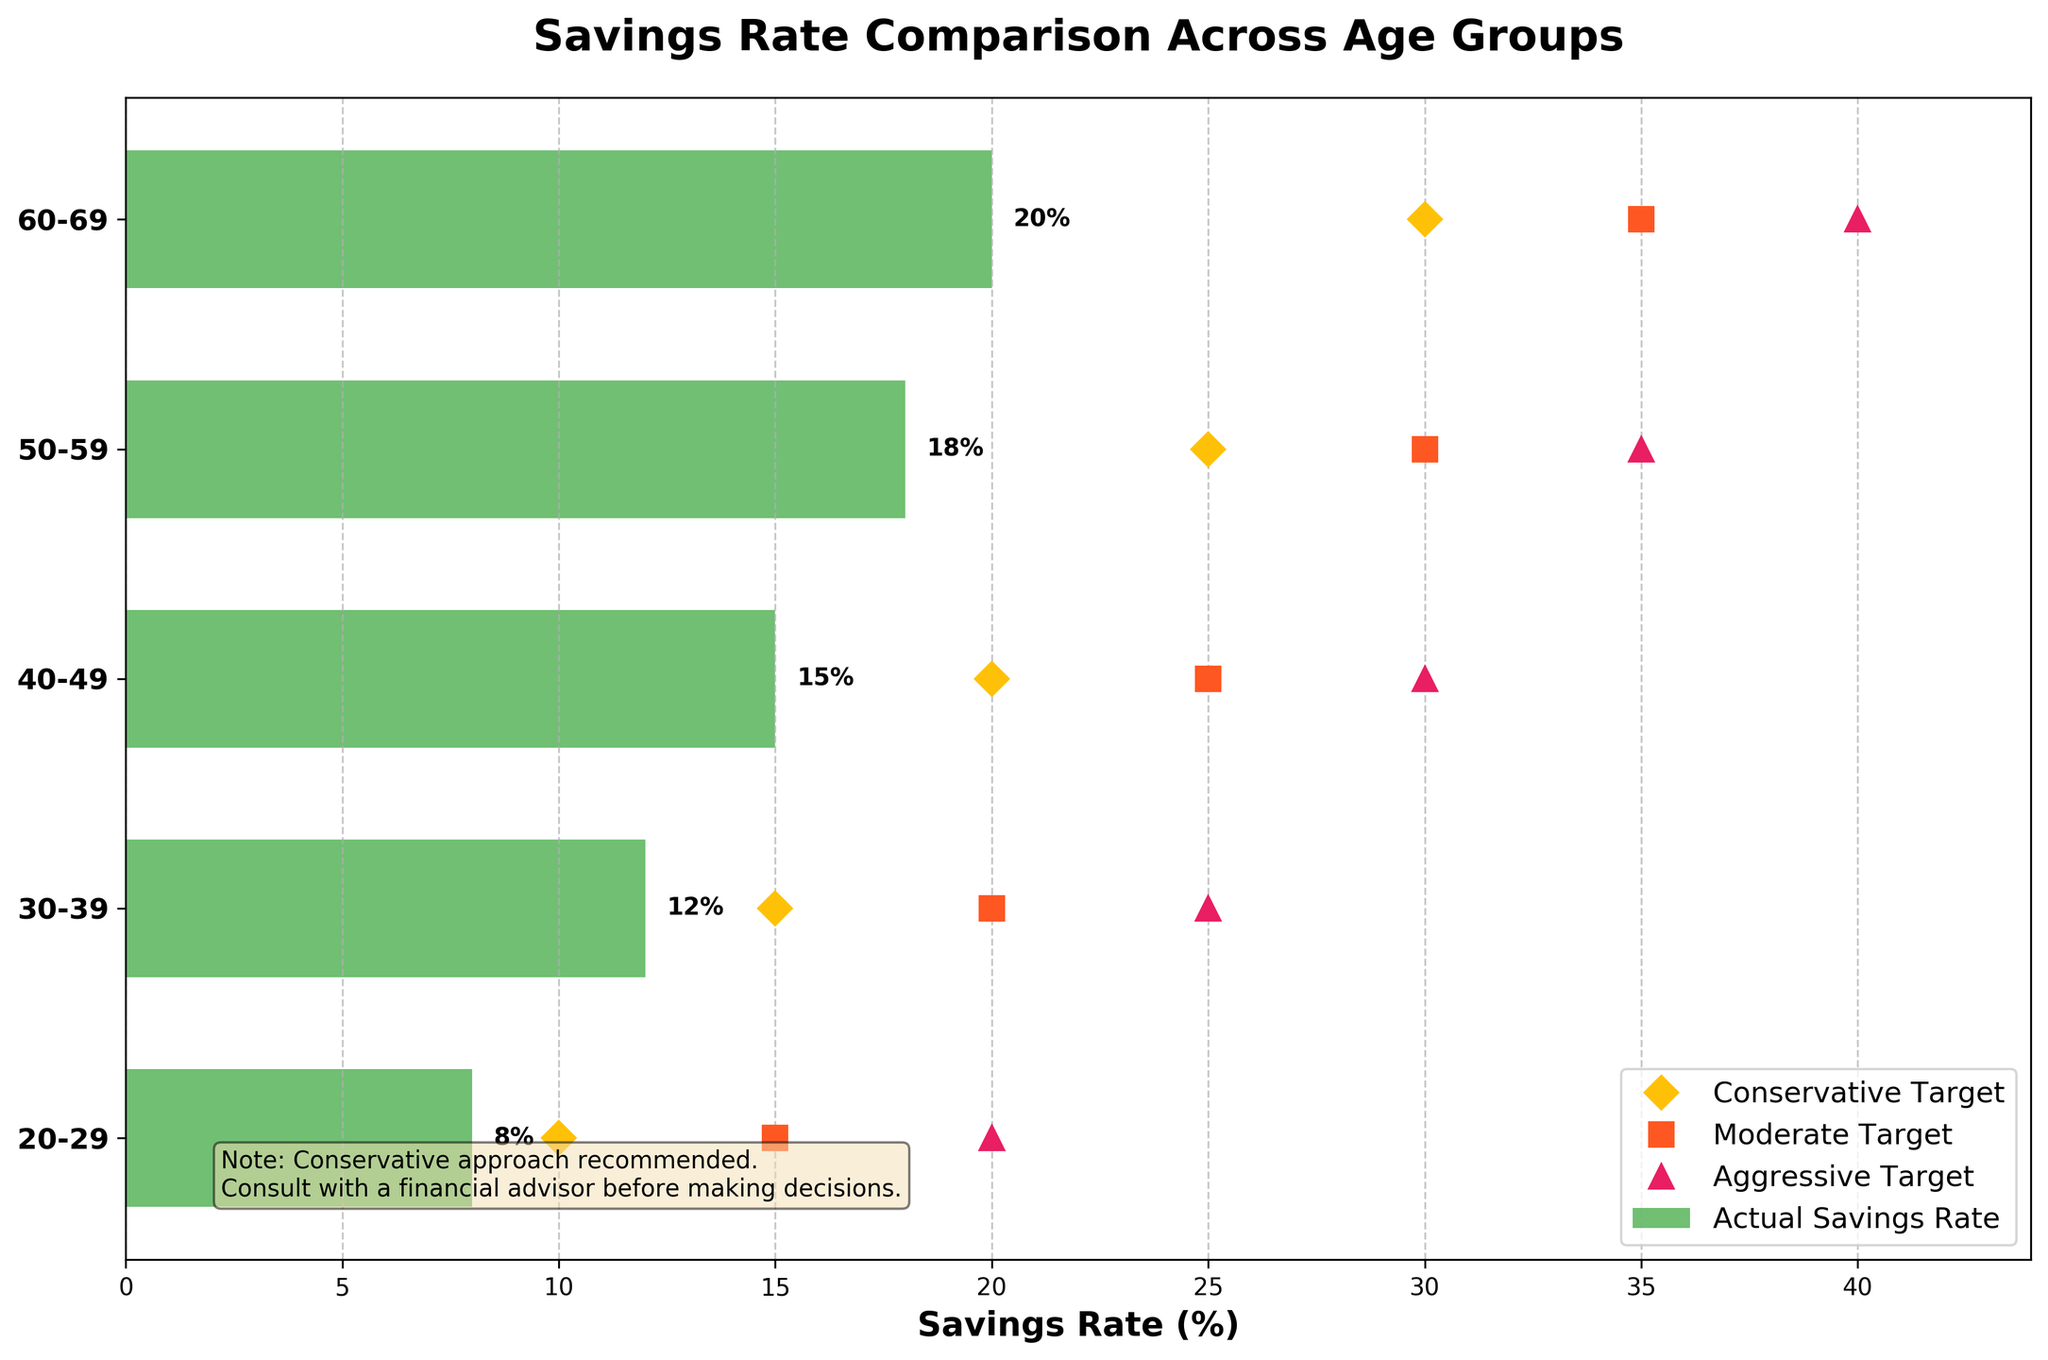What is the title of the figure? The title of the figure is usually located at the top center of the plot and indicates what the plot is about. In this case, the title is displayed as "Savings Rate Comparison Across Age Groups".
Answer: Savings Rate Comparison Across Age Groups What does the x-axis represent? The x-axis represents the Savings Rate in percentage (%), as indicated by the label "Savings Rate (%)". This label is found on the bottom part of the x-axis.
Answer: Savings Rate (%) How many age groups are displayed in the figure? The figure has one bar for each age group showing the Actual Savings Rate, and we can count the number of distinct bars. Here, the age groups shown are 20-29, 30-39, 40-49, 50-59, and 60-69.
Answer: 5 Which age group has the highest actual savings rate? By examining the length of the green bars, which represent the actual savings rate, it's clear that the 60-69 age group has the highest bar, indicating the highest actual savings rate at 20%.
Answer: 60-69 What color represents the conservative target? The conservative target is marked by diamonds on the plot. By inspecting the plot legend, we see that the conservative target is represented in yellow.
Answer: Yellow What's the difference between the actual savings rate and the conservative target for the 50-59 age group? The actual savings rate for the 50-59 age group is 18%, and the conservative target is 25%. The difference is calculated as 25 - 18.
Answer: 7% Which age group exceeds their conservative target? By comparing the green bars’ lengths with the diamond markers for all age groups, none of the age groups' actual savings rates (8%, 12%, 15%, 18%, 20%) exceed their respective conservative targets (10%, 15%, 20%, 25%, 30%).
Answer: None Which age group has the smallest gap to reach the conservative target? To find the smallest gap, calculate the difference between the actual savings rate and the conservative target for each age group and find the minimum. The smallest gap is for the 30-39 age group: 15 - 12 = 3%.
Answer: 30-39 How does the savings rate change with age groups? From the actual savings rates plotted, we observe that the savings rate increases with each successive age group: it goes from 8% in the 20-29 group to 20% in the 60-69 group.
Answer: Increases What message is given in the text box on the figure? The text box contains a cautionary message, which states: "Note: Conservative approach recommended. Consult with a financial advisor before making decisions."
Answer: Conservative approach recommended, consult with a financial advisor before making decisions 